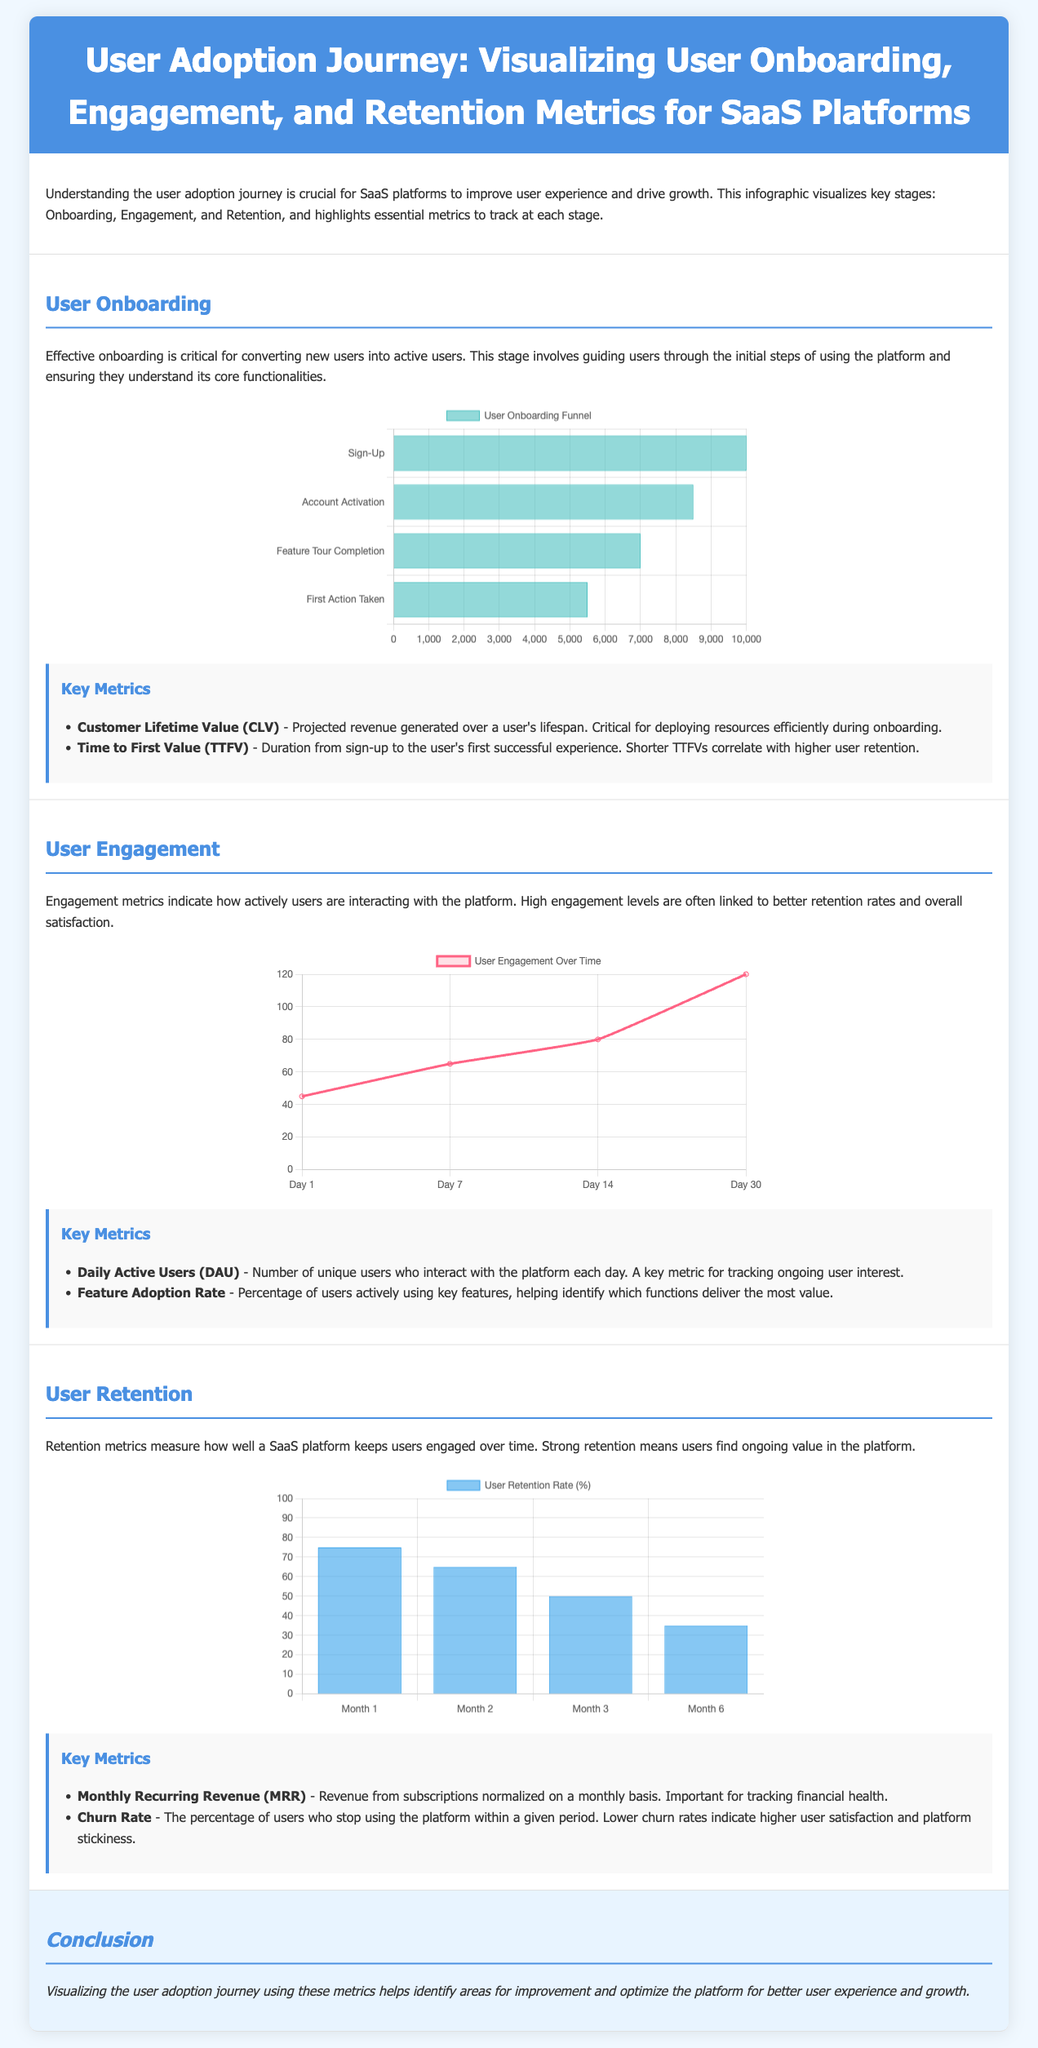what is the projected revenue generated over a user's lifespan? The document states that Customer Lifetime Value (CLV) is the projected revenue generated over a user's lifespan.
Answer: Customer Lifetime Value what is the percentage of users who stop using the platform within a given period? The document defines Churn Rate as the percentage of users who stop using the platform within a given period.
Answer: Churn Rate how many users complete the first action taken in the onboarding funnel? According to the onboarding funnel chart, 5500 users complete the first action taken.
Answer: 5500 what is the number of unique users interacting with the platform on Day 30? The engagement chart indicates that 120 unique users are engaging with the platform on Day 30.
Answer: 120 what is the user retention rate in Month 2? The retention cohort chart shows that the user retention rate in Month 2 is 65%.
Answer: 65% what happens to time to first value as onboarding improves? A shorter Time to First Value (TTFV) correlates with higher user retention, indicating that as onboarding improves, TTFV decreases.
Answer: Decreases what is the relationship between Daily Active Users and user interest? Daily Active Users (DAU) is a key metric for tracking ongoing user interest, indicating that higher DAUs reflect greater user interest.
Answer: Higher DAUs reflect greater user interest what does the visualization of the user adoption journey help identify? The visualization helps identify areas for improvement and optimize the platform for better user experience and growth.
Answer: Areas for improvement how many users are there at the account activation stage in the onboarding funnel? The onboarding funnel chart shows that there are 8500 users at the account activation stage.
Answer: 8500 